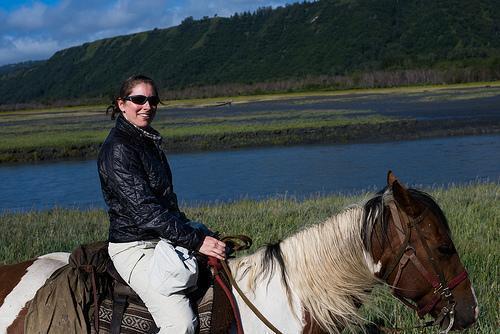How many people in picture?
Give a very brief answer. 1. 